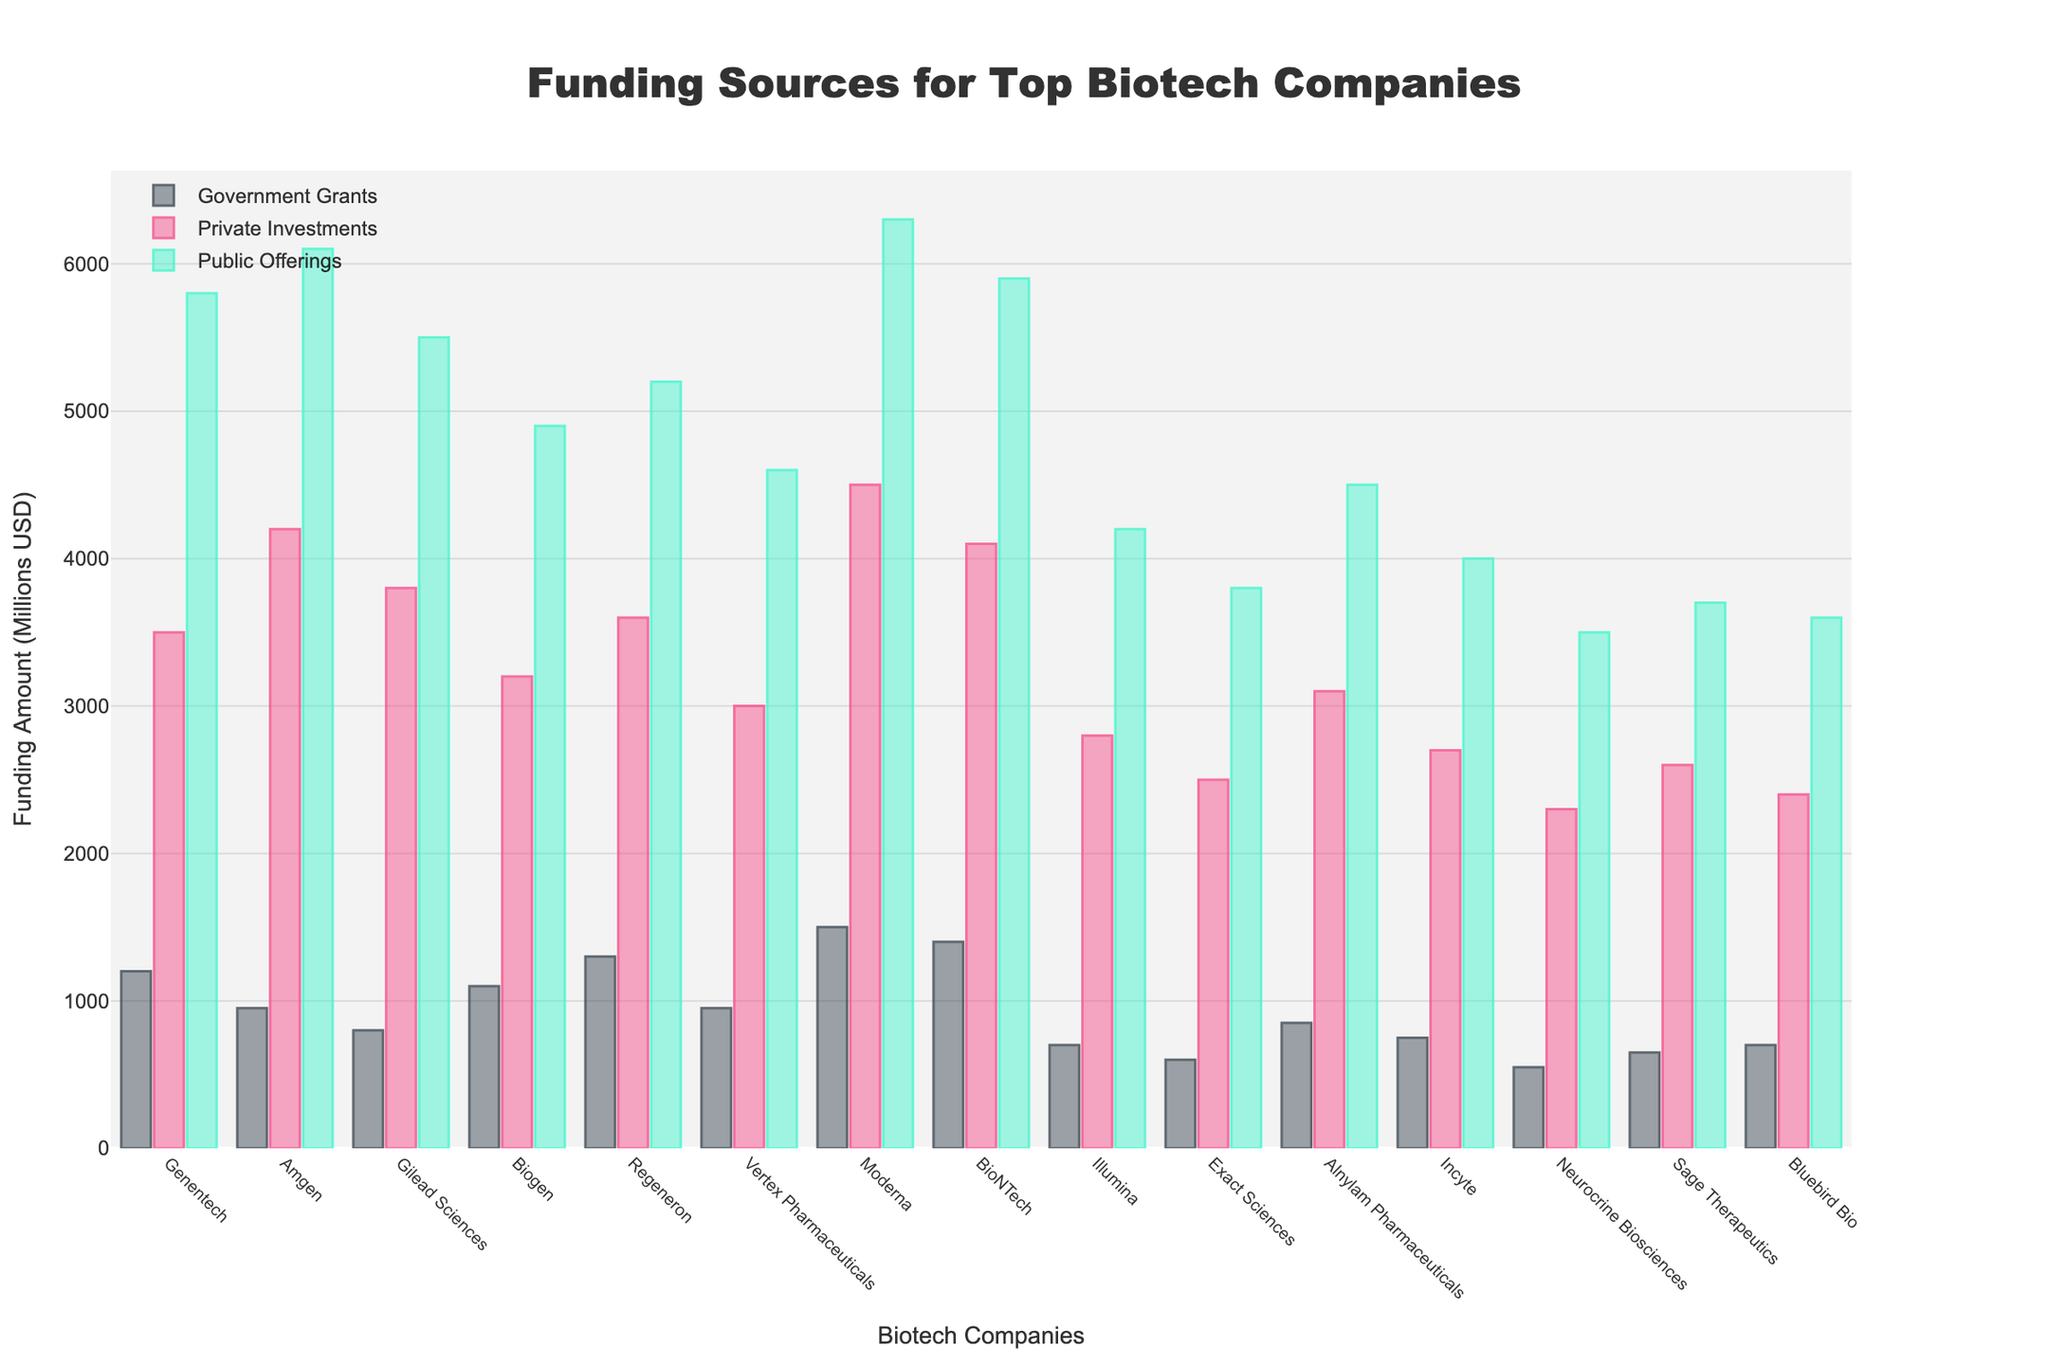What company received the highest amount of government grants? Look for the company with the tallest bar in the "Government Grants" category. Moderna has the highest amount with 1500 million USD.
Answer: Moderna Which company has the lowest funding from private investments? Identify the shortest bar in the "Private Investments" category. Neurocrine Biosciences received the lowest funding with 2300 million USD.
Answer: Neurocrine Biosciences What is the total funding amount (from all sources) for BioNTech? Sum the amounts for BioNTech from all three categories: 1400 (Government Grants) + 4100 (Private Investments) + 5900 (Public Offerings) = 11400 million USD.
Answer: 11400 million USD How does the public offering funding for Gilead Sciences compare to that of Amgen? Compare the heights of the bars in the "Public Offerings" category for Gilead Sciences and Amgen. Amgen's public offering is slightly higher at 6100 million USD compared to Gilead Sciences' 5500 million USD.
Answer: Amgen has higher public offerings Which funding source is the most evenly distributed across the companies? Compare the variation in heights of the bars across each funding source. "Government Grants" appears to be the most evenly distributed as the bar heights are more consistent compared to the other categories.
Answer: Government Grants What’s the combined funding from private investments for the top three companies in this category? Identify the three companies with the tallest bars in the "Private Investments" category: Amgen (4200), Moderna (4500), and BioNTech (4100). Sum these amounts: 4200 + 4500 + 4100 = 12800 million USD.
Answer: 12800 million USD Which company has the closest total funding amount to Illumina? Total funding for Illumina is 700 (Government Grants) + 2800 (Private Investments) + 4200 (Public Offerings) = 7700 million USD. Compare this with the total funding for other companies. Neurocrine Biosciences has the total funding of 550 + 2300 + 3500 = 6350, and Sage Therapeutics has 650 + 2600 + 3700 = 6950. The closest is Sage Therapeutics.
Answer: Sage Therapeutics What is the average funding from public offerings across all companies? Sum the public offerings for all companies and divide by the number of companies. Total public offerings: 5800 + 6100 + 5500 + 4900 + 5200 + 4600 + 6300 + 5900 + 4200 + 3800 + 4500 + 4000 + 3500 + 3700 + 3600 = 74600. Number of companies: 15. Average = 74600 / 15 = 4973.33 million USD.
Answer: 4973.33 million USD Are there any companies that received more government grants than private investments? Compare the heights of the bars in the "Government Grants" and "Private Investments" categories for each company. No company received more government grants than private investments as the "Private Investments" bars are taller in all cases.
Answer: No 